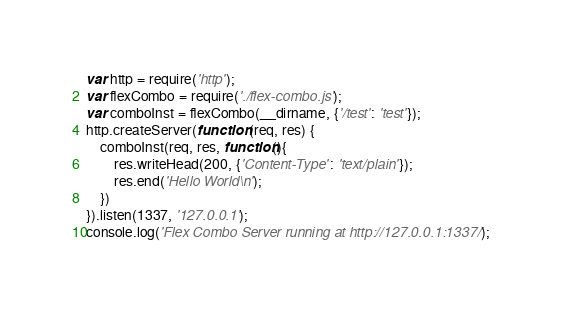<code> <loc_0><loc_0><loc_500><loc_500><_JavaScript_>var http = require('http');
var flexCombo = require('./flex-combo.js');
var comboInst = flexCombo(__dirname, {'/test': 'test'});
http.createServer(function (req, res) {
    comboInst(req, res, function(){
        res.writeHead(200, {'Content-Type': 'text/plain'});
        res.end('Hello World\n');
    })
}).listen(1337, '127.0.0.1');
console.log('Flex Combo Server running at http://127.0.0.1:1337/');
</code> 